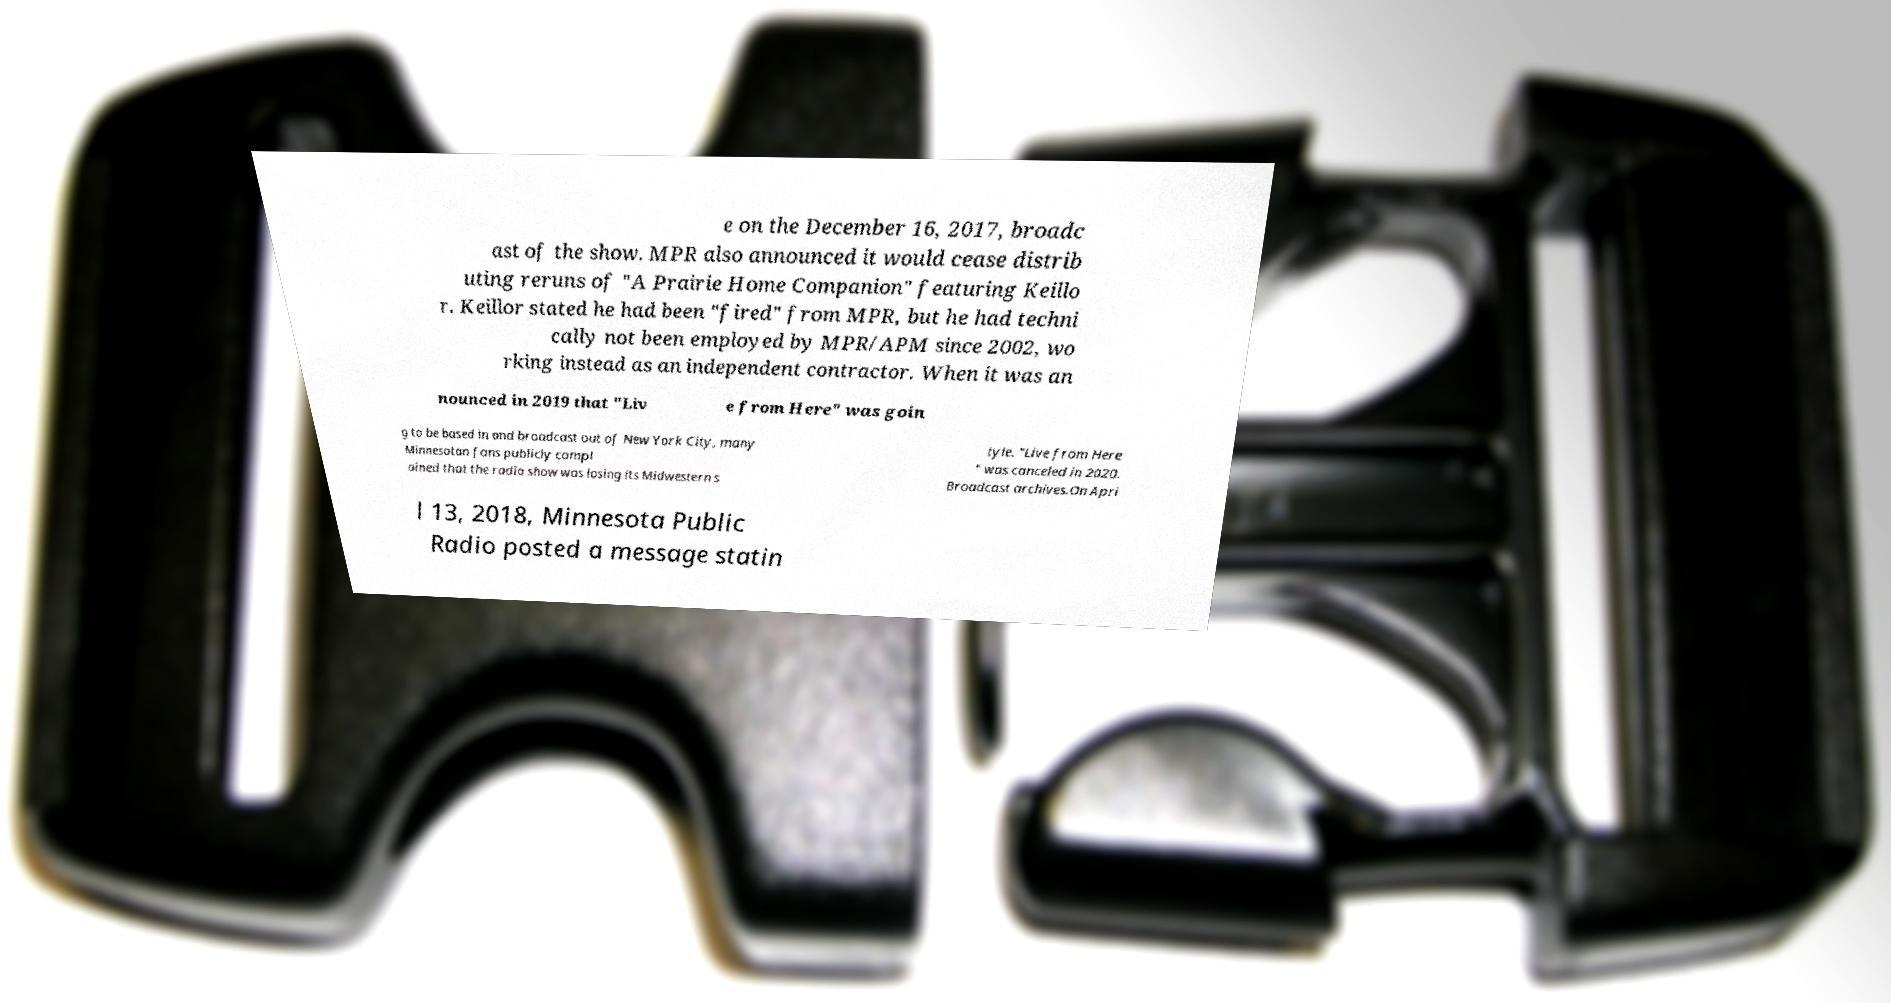Please identify and transcribe the text found in this image. e on the December 16, 2017, broadc ast of the show. MPR also announced it would cease distrib uting reruns of "A Prairie Home Companion" featuring Keillo r. Keillor stated he had been "fired" from MPR, but he had techni cally not been employed by MPR/APM since 2002, wo rking instead as an independent contractor. When it was an nounced in 2019 that "Liv e from Here" was goin g to be based in and broadcast out of New York City, many Minnesotan fans publicly compl ained that the radio show was losing its Midwestern s tyle. "Live from Here " was canceled in 2020. Broadcast archives.On Apri l 13, 2018, Minnesota Public Radio posted a message statin 